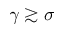Convert formula to latex. <formula><loc_0><loc_0><loc_500><loc_500>\gamma \gtrsim \sigma</formula> 